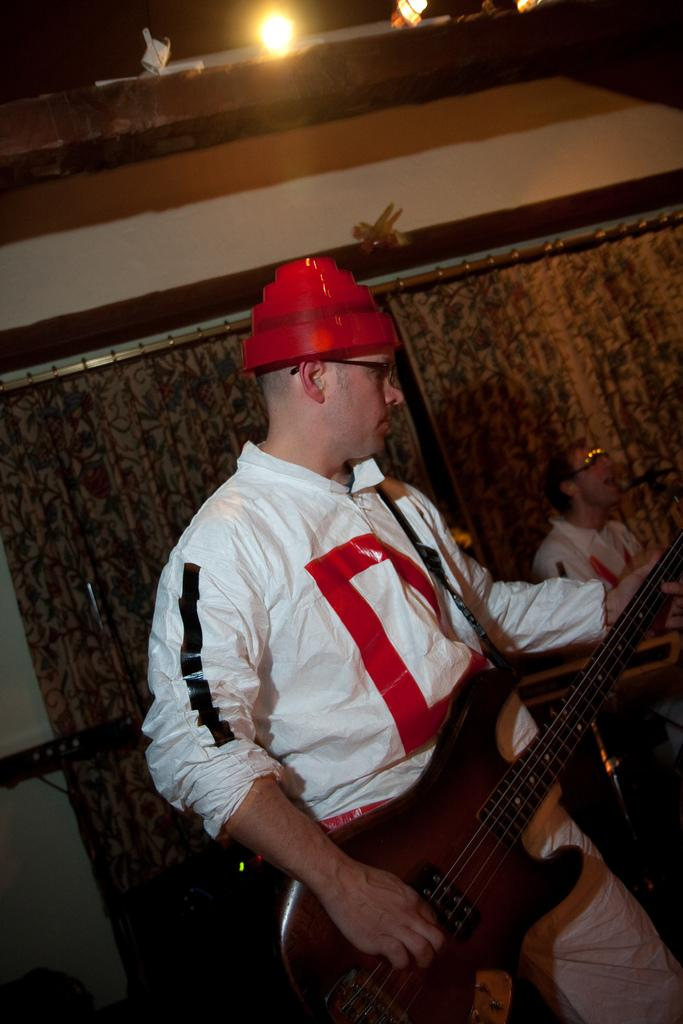Who is present in the image? There is a man in the image. What is the man doing in the image? The man is standing in the image. What object is the man holding in the image? The man is holding a guitar in his hand. What can be seen in the background of the image? There are curtains in the background of the image. What type of dinosaurs can be seen in the image? There are no dinosaurs present in the image; it features a man holding a guitar. How deep is the stream visible in the image? There is no stream present in the image. 